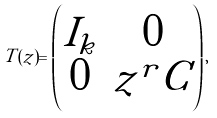<formula> <loc_0><loc_0><loc_500><loc_500>T ( z ) = \begin{pmatrix} I _ { k } & 0 \\ 0 & z ^ { r } C \end{pmatrix} ,</formula> 